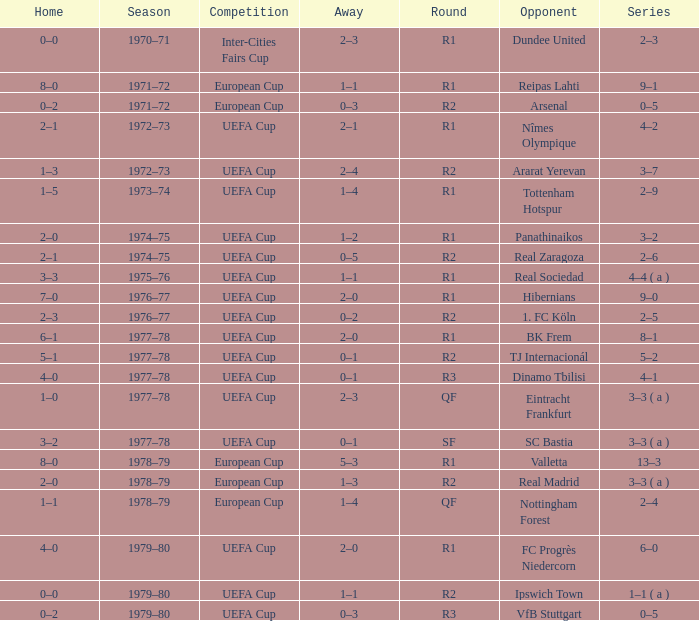Which Season has an Opponent of hibernians? 1976–77. 